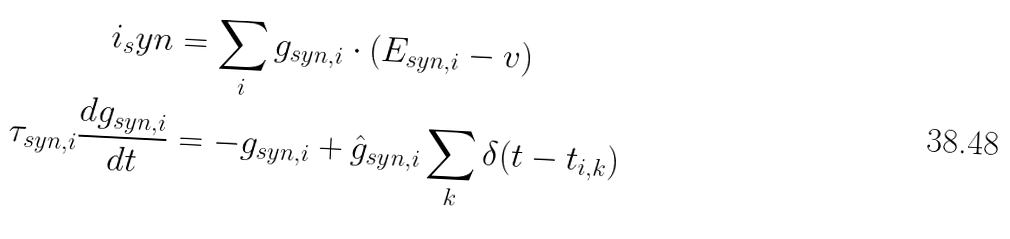<formula> <loc_0><loc_0><loc_500><loc_500>i _ { s } y n & = \sum _ { i } g _ { s y n , i } \cdot ( E _ { s y n , i } - v ) \\ \tau _ { s y n , i } \frac { d g _ { s y n , i } } { d t } & = - g _ { s y n , i } + \hat { g } _ { s y n , i } \sum _ { k } \delta ( t - t _ { i , k } )</formula> 